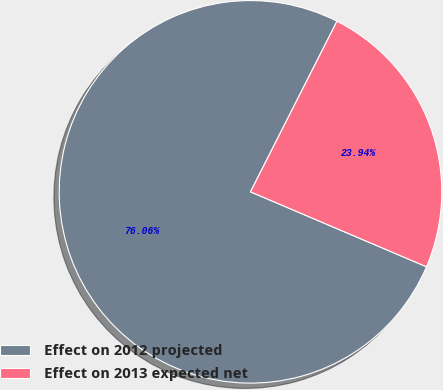<chart> <loc_0><loc_0><loc_500><loc_500><pie_chart><fcel>Effect on 2012 projected<fcel>Effect on 2013 expected net<nl><fcel>76.06%<fcel>23.94%<nl></chart> 